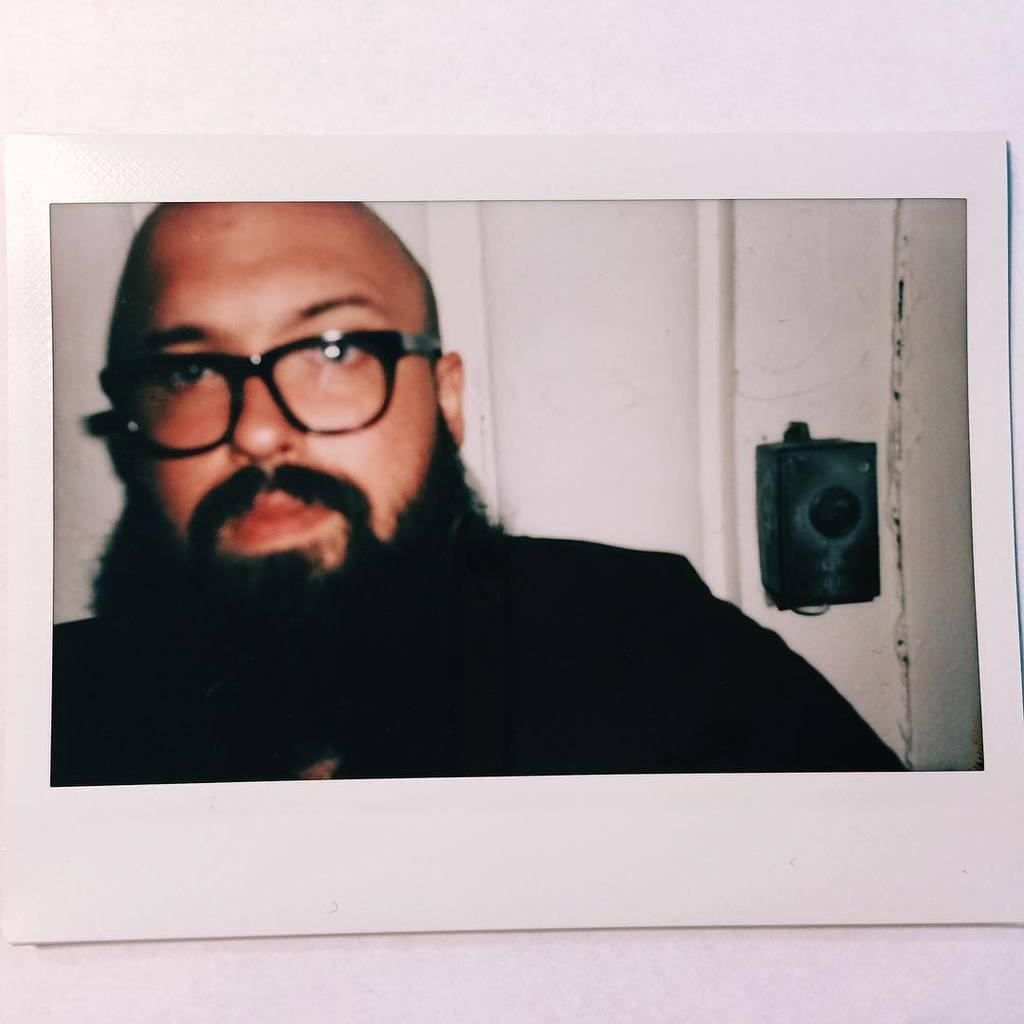Could you give a brief overview of what you see in this image? The picture consists of a photograph, in the photograph there is a person with beard, behind him there is door. on the right there is a black object. 